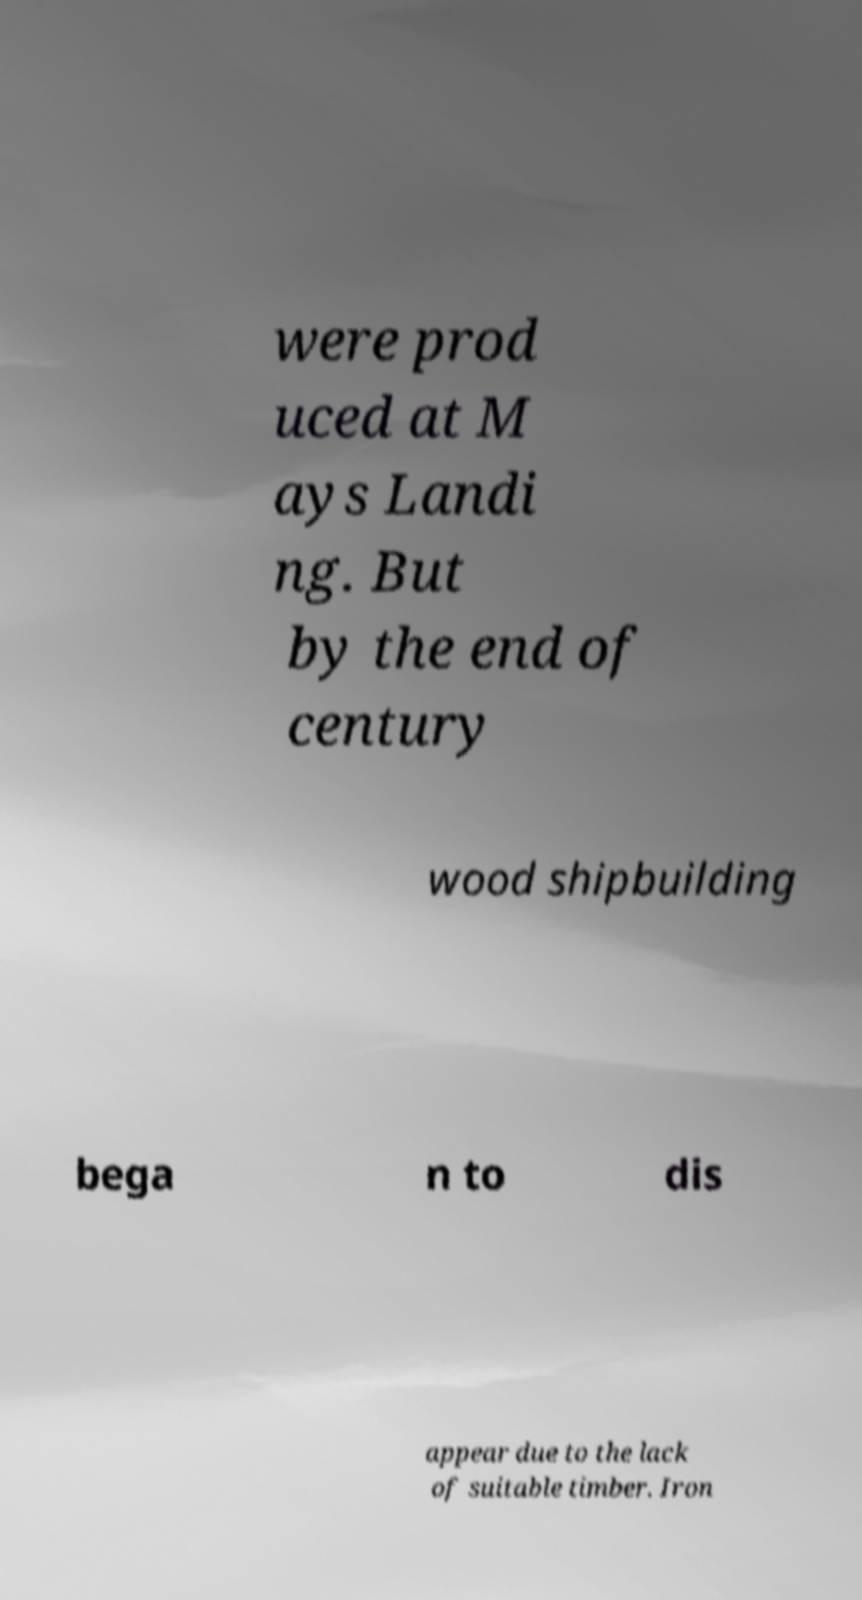I need the written content from this picture converted into text. Can you do that? were prod uced at M ays Landi ng. But by the end of century wood shipbuilding bega n to dis appear due to the lack of suitable timber. Iron 